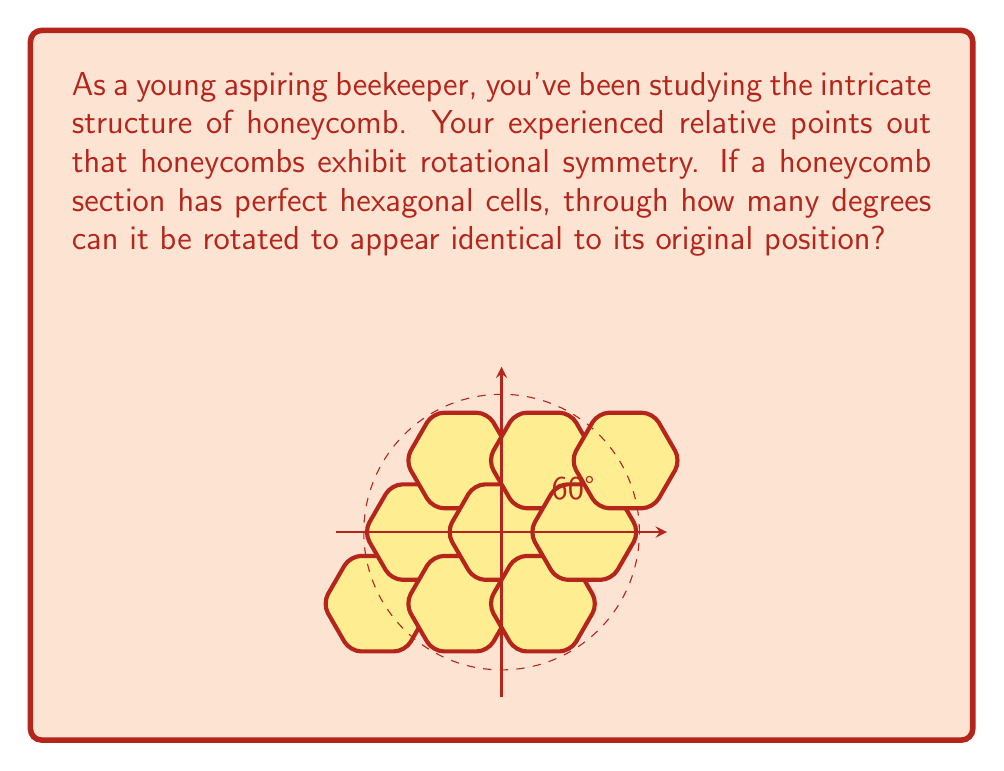Teach me how to tackle this problem. To solve this problem, let's analyze the symmetry of a hexagonal cell in the honeycomb:

1) A regular hexagon has 6 sides and 6 vertices.

2) Rotational symmetry occurs when an object can be rotated around a central point and appear identical to its original position.

3) For a regular hexagon, we can achieve this by rotating it in multiples of 60°:

   $$\frac{360°}{6} = 60°$$

4) The honeycomb pattern is made up of these hexagonal cells, so it inherits the same rotational symmetry.

5) Therefore, the honeycomb can be rotated by 60°, 120°, 180°, 240°, 300°, and 360° to appear identical to its original position.

6) The question asks for the smallest non-zero rotation that achieves this, which is 60°.

This 60° rotation is significant in beekeeping as it reflects the efficiency of bees in creating a structure that maximizes space usage while minimizing material (wax) consumption.
Answer: 60° 